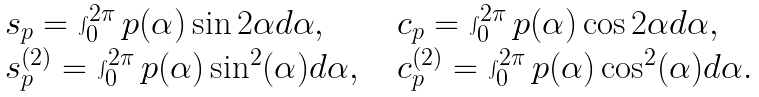<formula> <loc_0><loc_0><loc_500><loc_500>\begin{array} { l l l } s _ { p } = \int _ { 0 } ^ { 2 \pi } p ( \alpha ) \sin 2 \alpha d \alpha , & \, & c _ { p } = \int _ { 0 } ^ { 2 \pi } p ( \alpha ) \cos 2 \alpha d \alpha , \\ s ^ { ( 2 ) } _ { p } = \int _ { 0 } ^ { 2 \pi } p ( \alpha ) \sin ^ { 2 } ( \alpha ) d \alpha , & \, & c ^ { ( 2 ) } _ { p } = \int _ { 0 } ^ { 2 \pi } p ( \alpha ) \cos ^ { 2 } ( \alpha ) d \alpha . \end{array}</formula> 